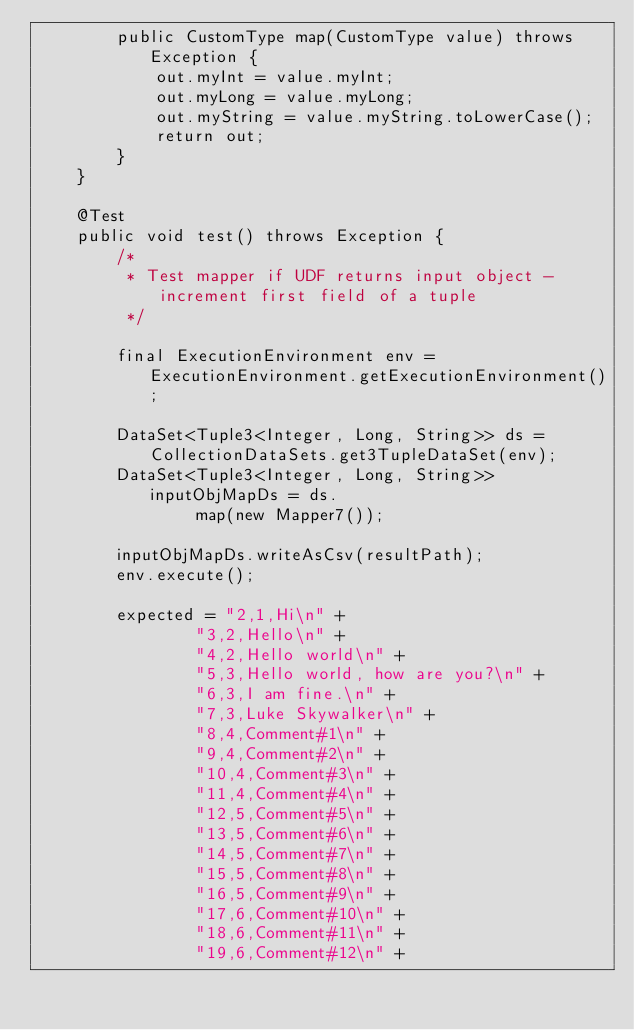<code> <loc_0><loc_0><loc_500><loc_500><_Java_>		public CustomType map(CustomType value) throws Exception {
			out.myInt = value.myInt;
			out.myLong = value.myLong;
			out.myString = value.myString.toLowerCase();
			return out;
		}
	}

	@Test
	public void test() throws Exception {
		/*
		 * Test mapper if UDF returns input object - increment first field of a tuple
		 */

		final ExecutionEnvironment env = ExecutionEnvironment.getExecutionEnvironment();

		DataSet<Tuple3<Integer, Long, String>> ds = CollectionDataSets.get3TupleDataSet(env);
		DataSet<Tuple3<Integer, Long, String>> inputObjMapDs = ds.
				map(new Mapper7());

		inputObjMapDs.writeAsCsv(resultPath);
		env.execute();

		expected = "2,1,Hi\n" +
				"3,2,Hello\n" +
				"4,2,Hello world\n" +
				"5,3,Hello world, how are you?\n" +
				"6,3,I am fine.\n" +
				"7,3,Luke Skywalker\n" +
				"8,4,Comment#1\n" +
				"9,4,Comment#2\n" +
				"10,4,Comment#3\n" +
				"11,4,Comment#4\n" +
				"12,5,Comment#5\n" +
				"13,5,Comment#6\n" +
				"14,5,Comment#7\n" +
				"15,5,Comment#8\n" +
				"16,5,Comment#9\n" +
				"17,6,Comment#10\n" +
				"18,6,Comment#11\n" +
				"19,6,Comment#12\n" +</code> 